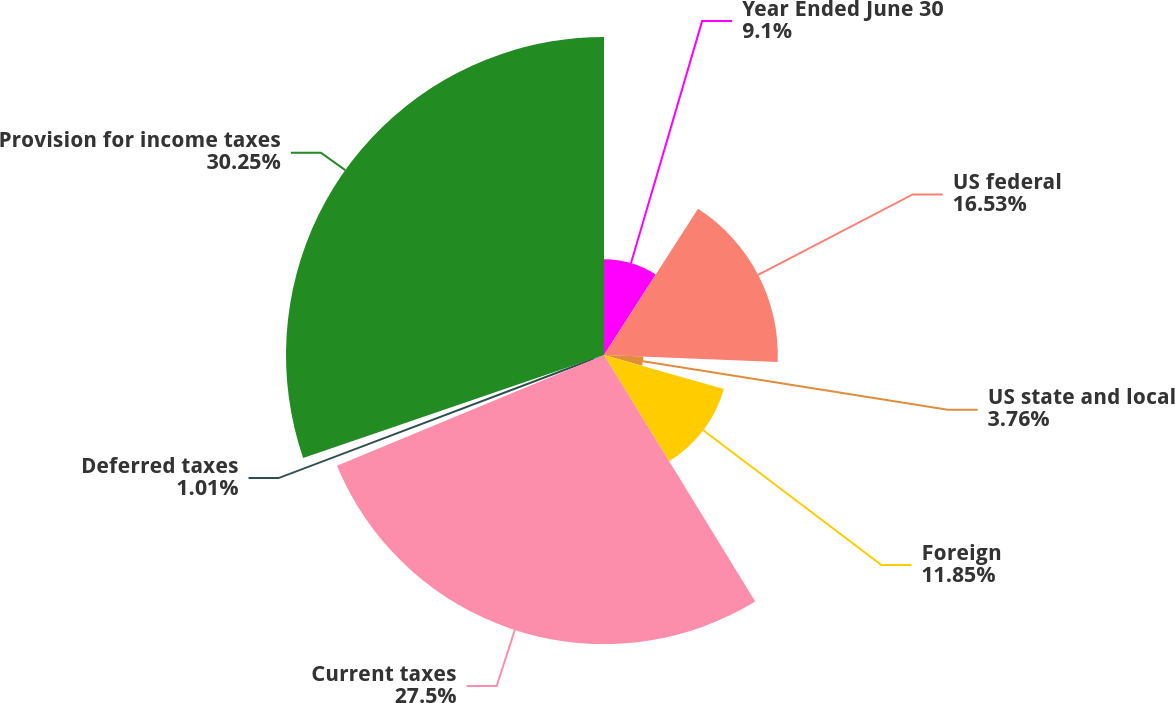<chart> <loc_0><loc_0><loc_500><loc_500><pie_chart><fcel>Year Ended June 30<fcel>US federal<fcel>US state and local<fcel>Foreign<fcel>Current taxes<fcel>Deferred taxes<fcel>Provision for income taxes<nl><fcel>9.1%<fcel>16.53%<fcel>3.76%<fcel>11.85%<fcel>27.5%<fcel>1.01%<fcel>30.25%<nl></chart> 